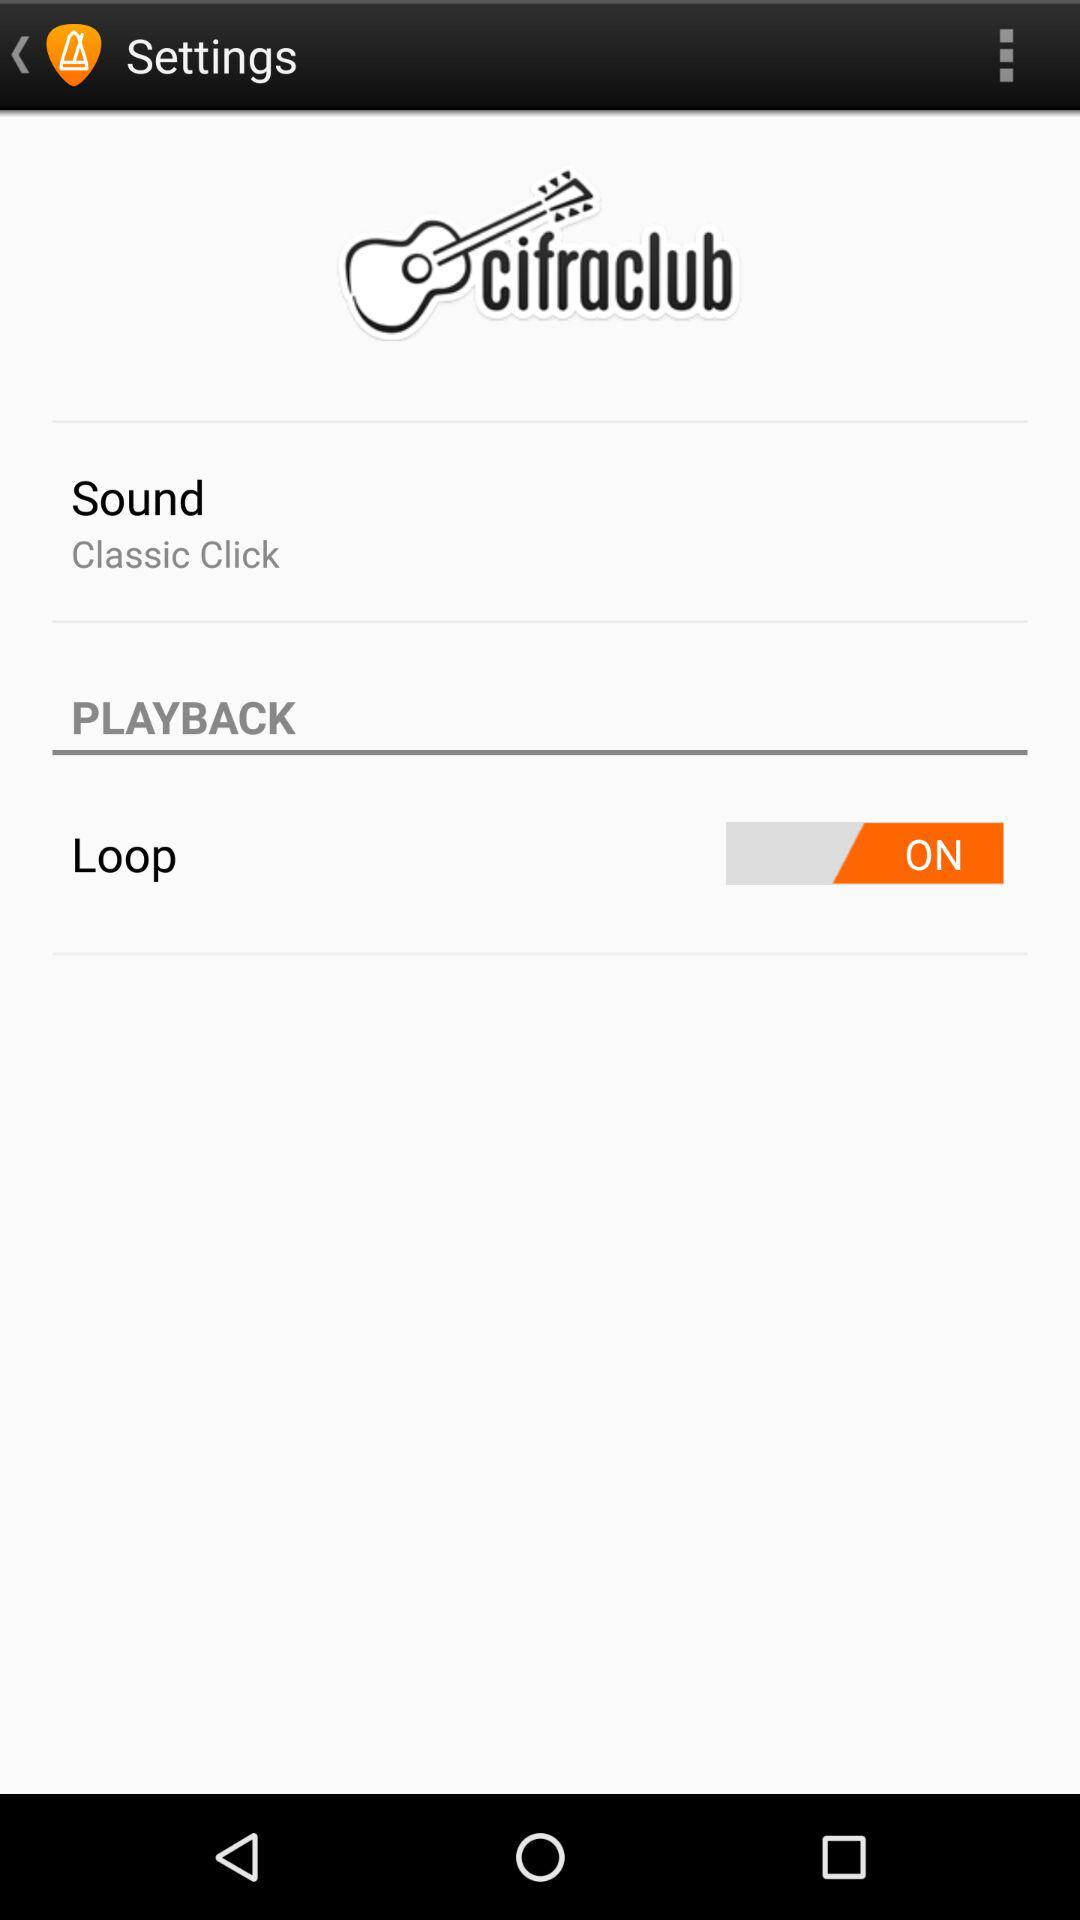What is the name of the application? The name of the application is "cifraclub". 